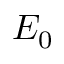Convert formula to latex. <formula><loc_0><loc_0><loc_500><loc_500>E _ { 0 }</formula> 